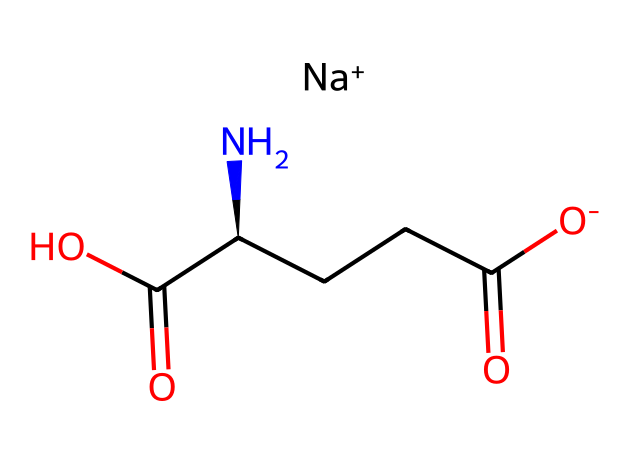What is the molecular formula of MSG? The molecular structure indicates the elements present: sodium (Na), carbon (C), hydrogen (H), nitrogen (N), and oxygen (O). By counting the atoms in the provided SMILES, we can derive that the formula is C5H8NNaO4.
Answer: C5H8NNaO4 How many carbon atoms are in MSG? By analyzing the SMILES representation, there are five 'C' characters indicating five carbon atoms present in the structure.
Answer: 5 What type of compound is MSG classified as? MSG contains a sodium ion, which makes it a type of electrolyte, particularly a sodium salt of an amino acid, since it has both amino (NH2) and carboxyl (COOH) functional groups.
Answer: electrolyte What is the charge on the sodium ion in MSG? In the provided SMILES, sodium is denoted as [Na+], which indicates that it carries a positive charge (+1).
Answer: +1 What is the total number of oxygen atoms in MSG? By examining the SMILES representation, we see the notation 'O' appears four times, indicating there are four oxygen atoms in the structure.
Answer: 4 Which part of MSG contributes to its flavor-enhancing properties? MSG's flavor-enhancing properties are primarily contributed by its amino acid structure, specifically the presence of the amino (NH2) group attached to the carbon chain.
Answer: amino group 